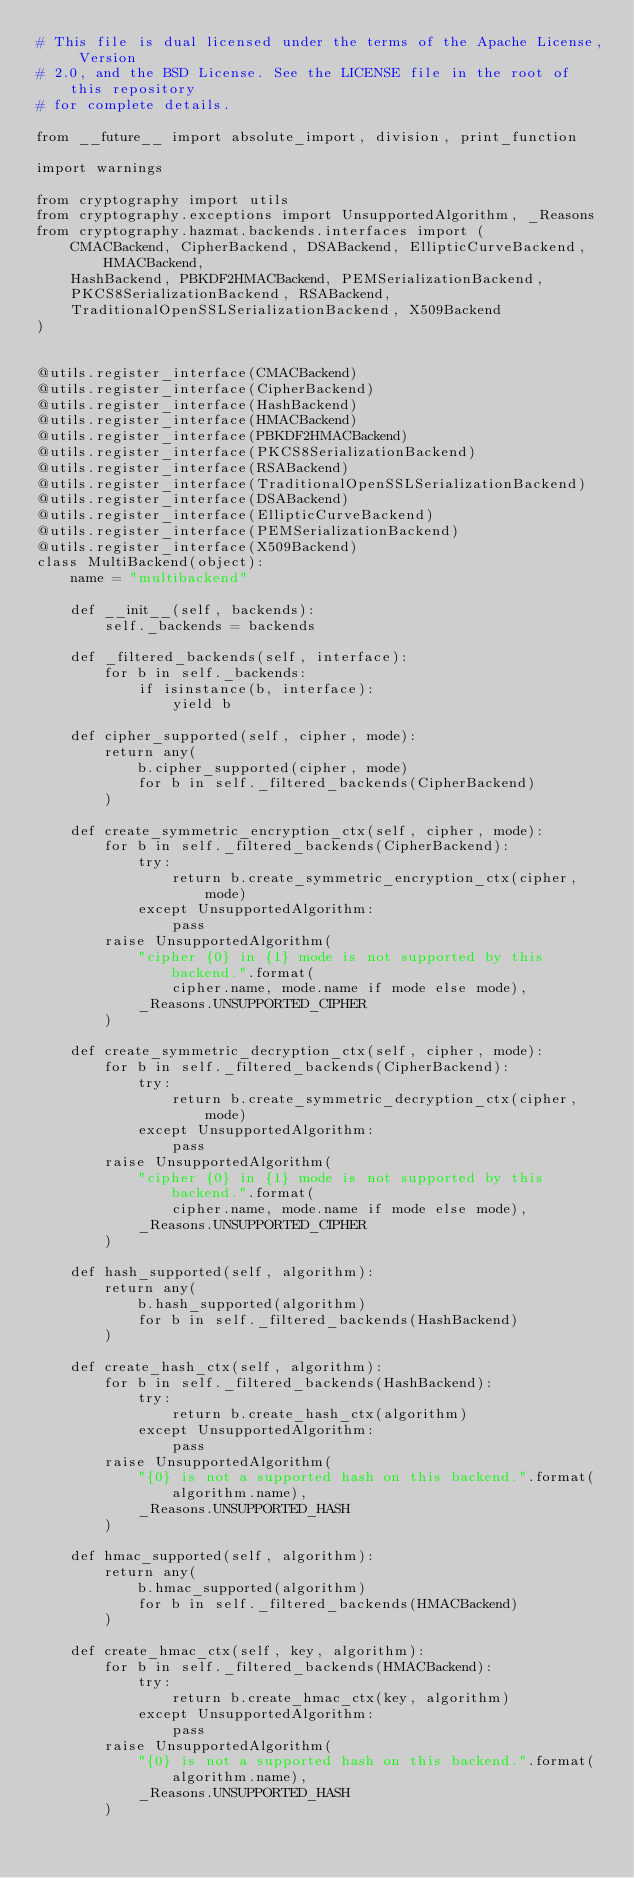<code> <loc_0><loc_0><loc_500><loc_500><_Python_># This file is dual licensed under the terms of the Apache License, Version
# 2.0, and the BSD License. See the LICENSE file in the root of this repository
# for complete details.

from __future__ import absolute_import, division, print_function

import warnings

from cryptography import utils
from cryptography.exceptions import UnsupportedAlgorithm, _Reasons
from cryptography.hazmat.backends.interfaces import (
    CMACBackend, CipherBackend, DSABackend, EllipticCurveBackend, HMACBackend,
    HashBackend, PBKDF2HMACBackend, PEMSerializationBackend,
    PKCS8SerializationBackend, RSABackend,
    TraditionalOpenSSLSerializationBackend, X509Backend
)


@utils.register_interface(CMACBackend)
@utils.register_interface(CipherBackend)
@utils.register_interface(HashBackend)
@utils.register_interface(HMACBackend)
@utils.register_interface(PBKDF2HMACBackend)
@utils.register_interface(PKCS8SerializationBackend)
@utils.register_interface(RSABackend)
@utils.register_interface(TraditionalOpenSSLSerializationBackend)
@utils.register_interface(DSABackend)
@utils.register_interface(EllipticCurveBackend)
@utils.register_interface(PEMSerializationBackend)
@utils.register_interface(X509Backend)
class MultiBackend(object):
    name = "multibackend"

    def __init__(self, backends):
        self._backends = backends

    def _filtered_backends(self, interface):
        for b in self._backends:
            if isinstance(b, interface):
                yield b

    def cipher_supported(self, cipher, mode):
        return any(
            b.cipher_supported(cipher, mode)
            for b in self._filtered_backends(CipherBackend)
        )

    def create_symmetric_encryption_ctx(self, cipher, mode):
        for b in self._filtered_backends(CipherBackend):
            try:
                return b.create_symmetric_encryption_ctx(cipher, mode)
            except UnsupportedAlgorithm:
                pass
        raise UnsupportedAlgorithm(
            "cipher {0} in {1} mode is not supported by this backend.".format(
                cipher.name, mode.name if mode else mode),
            _Reasons.UNSUPPORTED_CIPHER
        )

    def create_symmetric_decryption_ctx(self, cipher, mode):
        for b in self._filtered_backends(CipherBackend):
            try:
                return b.create_symmetric_decryption_ctx(cipher, mode)
            except UnsupportedAlgorithm:
                pass
        raise UnsupportedAlgorithm(
            "cipher {0} in {1} mode is not supported by this backend.".format(
                cipher.name, mode.name if mode else mode),
            _Reasons.UNSUPPORTED_CIPHER
        )

    def hash_supported(self, algorithm):
        return any(
            b.hash_supported(algorithm)
            for b in self._filtered_backends(HashBackend)
        )

    def create_hash_ctx(self, algorithm):
        for b in self._filtered_backends(HashBackend):
            try:
                return b.create_hash_ctx(algorithm)
            except UnsupportedAlgorithm:
                pass
        raise UnsupportedAlgorithm(
            "{0} is not a supported hash on this backend.".format(
                algorithm.name),
            _Reasons.UNSUPPORTED_HASH
        )

    def hmac_supported(self, algorithm):
        return any(
            b.hmac_supported(algorithm)
            for b in self._filtered_backends(HMACBackend)
        )

    def create_hmac_ctx(self, key, algorithm):
        for b in self._filtered_backends(HMACBackend):
            try:
                return b.create_hmac_ctx(key, algorithm)
            except UnsupportedAlgorithm:
                pass
        raise UnsupportedAlgorithm(
            "{0} is not a supported hash on this backend.".format(
                algorithm.name),
            _Reasons.UNSUPPORTED_HASH
        )
</code> 